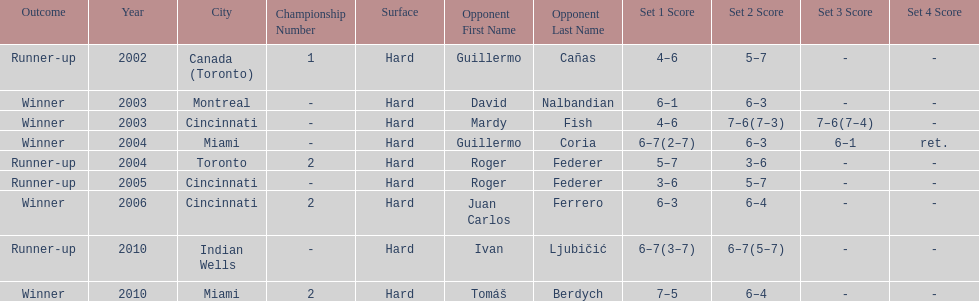What is his highest number of consecutive wins? 3. 